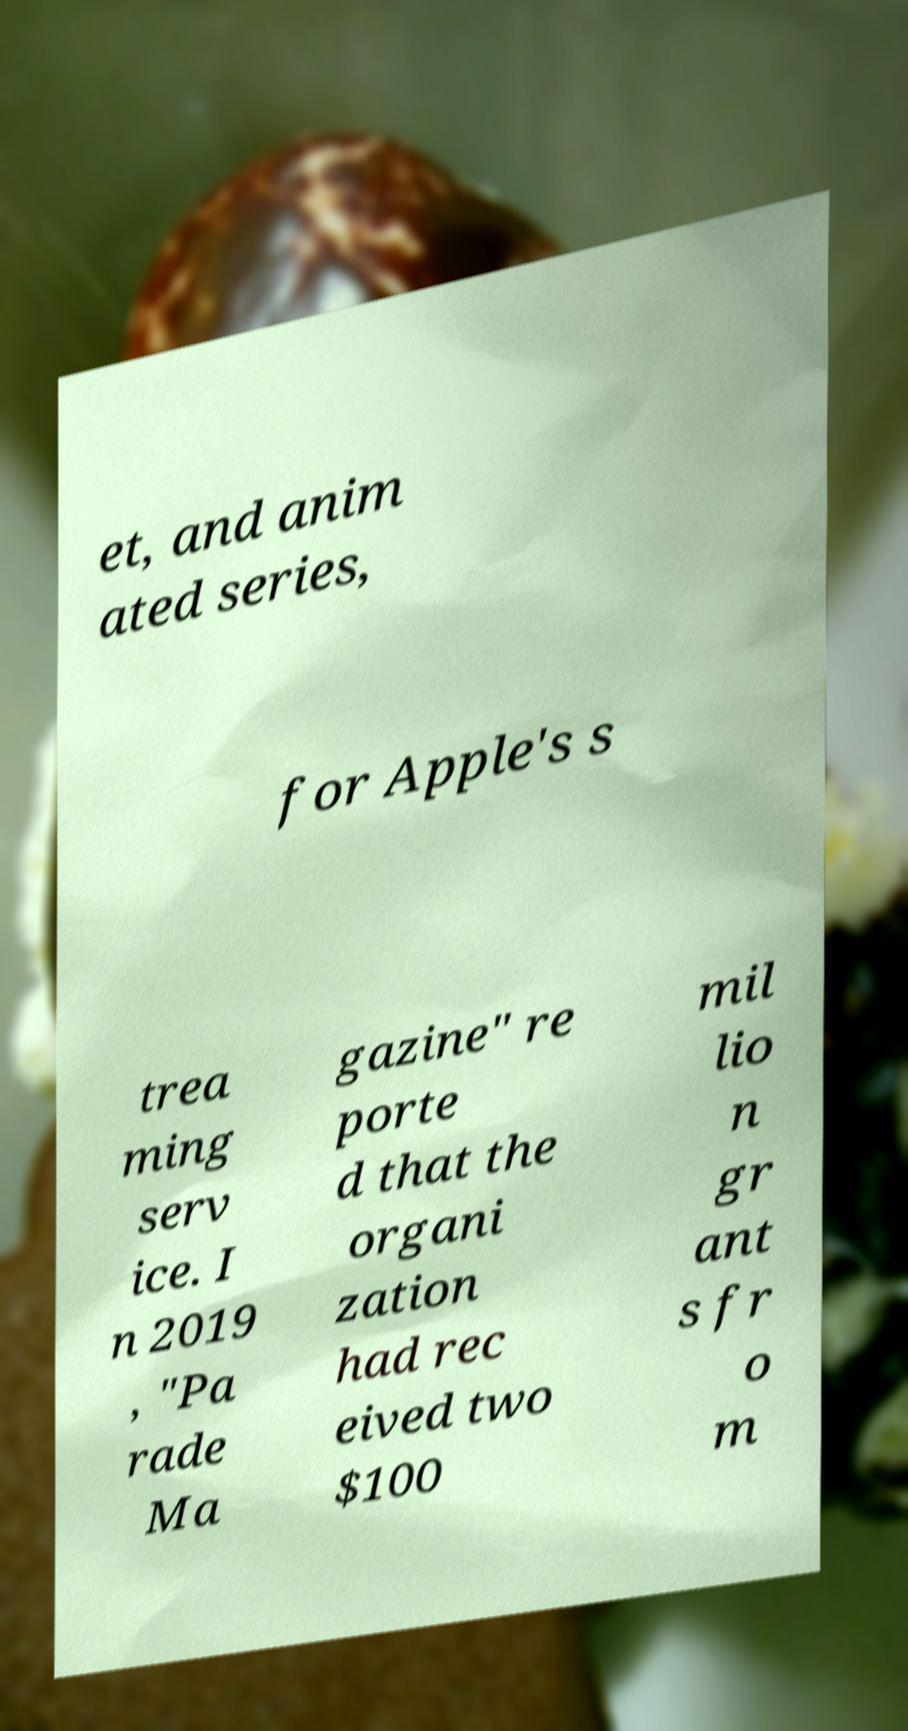Please read and relay the text visible in this image. What does it say? et, and anim ated series, for Apple's s trea ming serv ice. I n 2019 , "Pa rade Ma gazine" re porte d that the organi zation had rec eived two $100 mil lio n gr ant s fr o m 